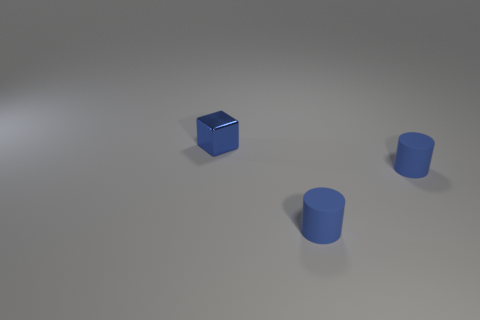Add 3 large gray metal blocks. How many objects exist? 6 Subtract all blocks. How many objects are left? 2 Add 3 blue shiny blocks. How many blue shiny blocks exist? 4 Subtract 0 cyan blocks. How many objects are left? 3 Subtract all rubber things. Subtract all cubes. How many objects are left? 0 Add 1 metallic blocks. How many metallic blocks are left? 2 